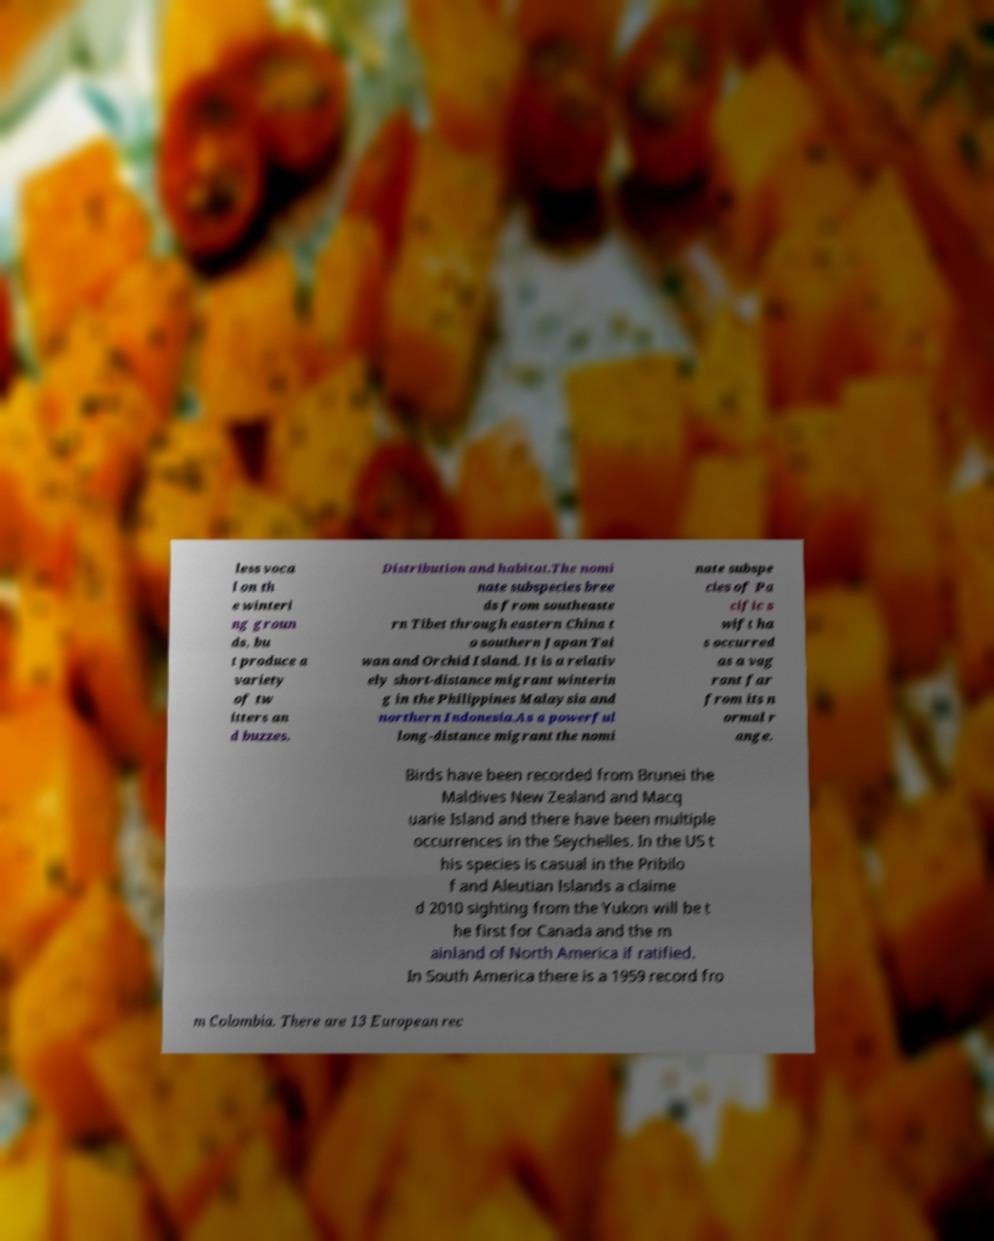What messages or text are displayed in this image? I need them in a readable, typed format. less voca l on th e winteri ng groun ds, bu t produce a variety of tw itters an d buzzes. Distribution and habitat.The nomi nate subspecies bree ds from southeaste rn Tibet through eastern China t o southern Japan Tai wan and Orchid Island. It is a relativ ely short-distance migrant winterin g in the Philippines Malaysia and northern Indonesia.As a powerful long-distance migrant the nomi nate subspe cies of Pa cific s wift ha s occurred as a vag rant far from its n ormal r ange. Birds have been recorded from Brunei the Maldives New Zealand and Macq uarie Island and there have been multiple occurrences in the Seychelles. In the US t his species is casual in the Pribilo f and Aleutian Islands a claime d 2010 sighting from the Yukon will be t he first for Canada and the m ainland of North America if ratified. In South America there is a 1959 record fro m Colombia. There are 13 European rec 